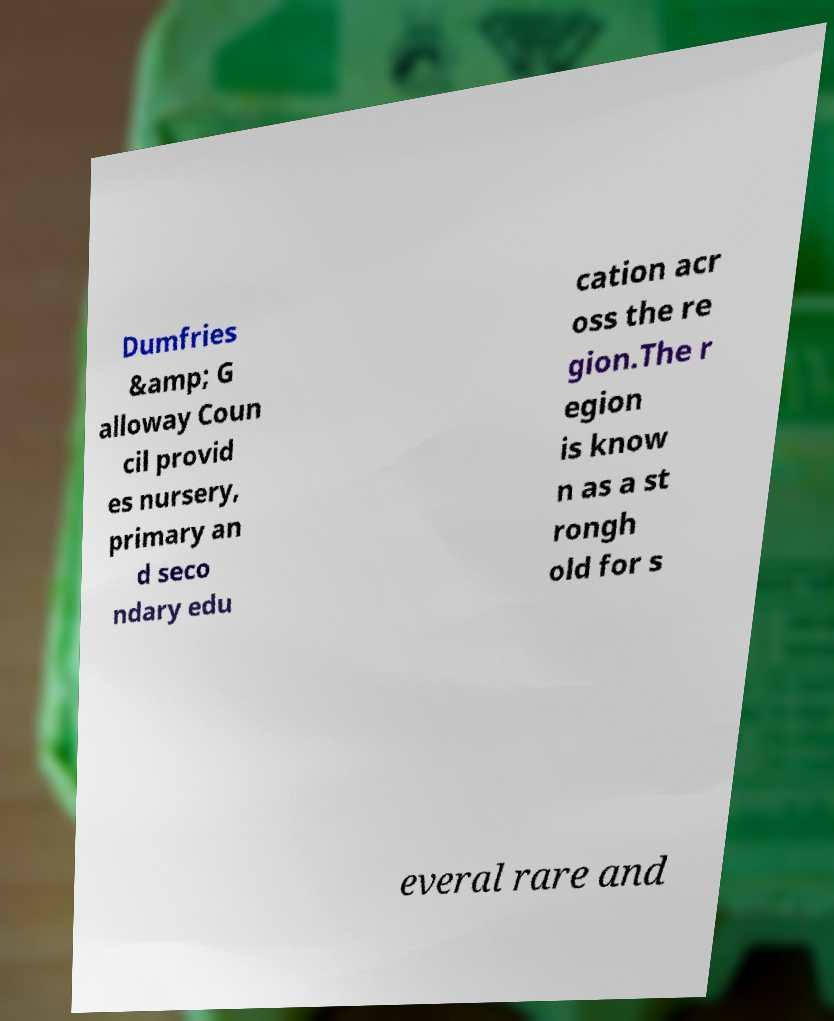I need the written content from this picture converted into text. Can you do that? Dumfries &amp; G alloway Coun cil provid es nursery, primary an d seco ndary edu cation acr oss the re gion.The r egion is know n as a st rongh old for s everal rare and 